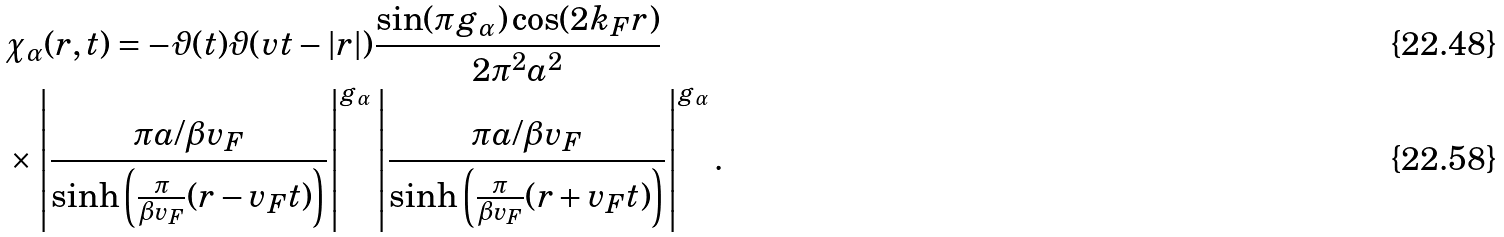<formula> <loc_0><loc_0><loc_500><loc_500>& \chi _ { \alpha } ( r , t ) = - \vartheta ( t ) \vartheta ( v t - | r | ) \frac { \sin ( \pi g _ { \alpha } ) \cos ( 2 k _ { F } r ) } { 2 \pi ^ { 2 } a ^ { 2 } } \\ & \times \left | \frac { \pi a / \beta v _ { F } } { \sinh \left ( \frac { \pi } { \beta v _ { F } } ( r - v _ { F } t ) \right ) } \right | ^ { g _ { \alpha } } \left | \frac { \pi a / \beta v _ { F } } { \sinh \left ( \frac { \pi } { \beta v _ { F } } ( r + v _ { F } t ) \right ) } \right | ^ { g _ { \alpha } } .</formula> 